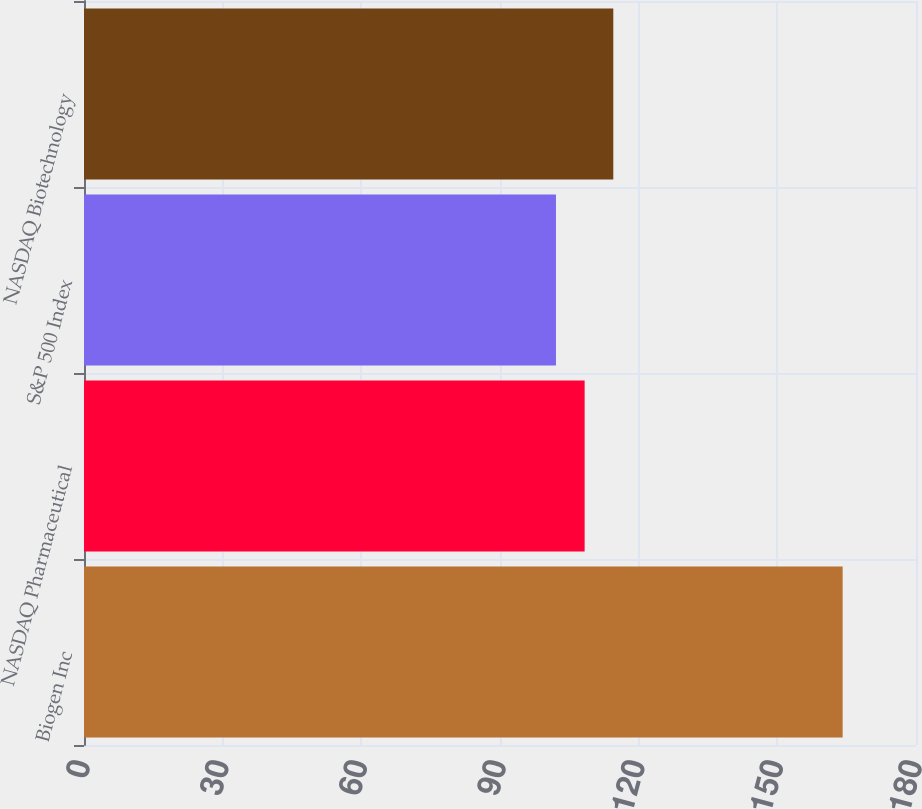<chart> <loc_0><loc_0><loc_500><loc_500><bar_chart><fcel>Biogen Inc<fcel>NASDAQ Pharmaceutical<fcel>S&P 500 Index<fcel>NASDAQ Biotechnology<nl><fcel>164.13<fcel>108.31<fcel>102.11<fcel>114.51<nl></chart> 